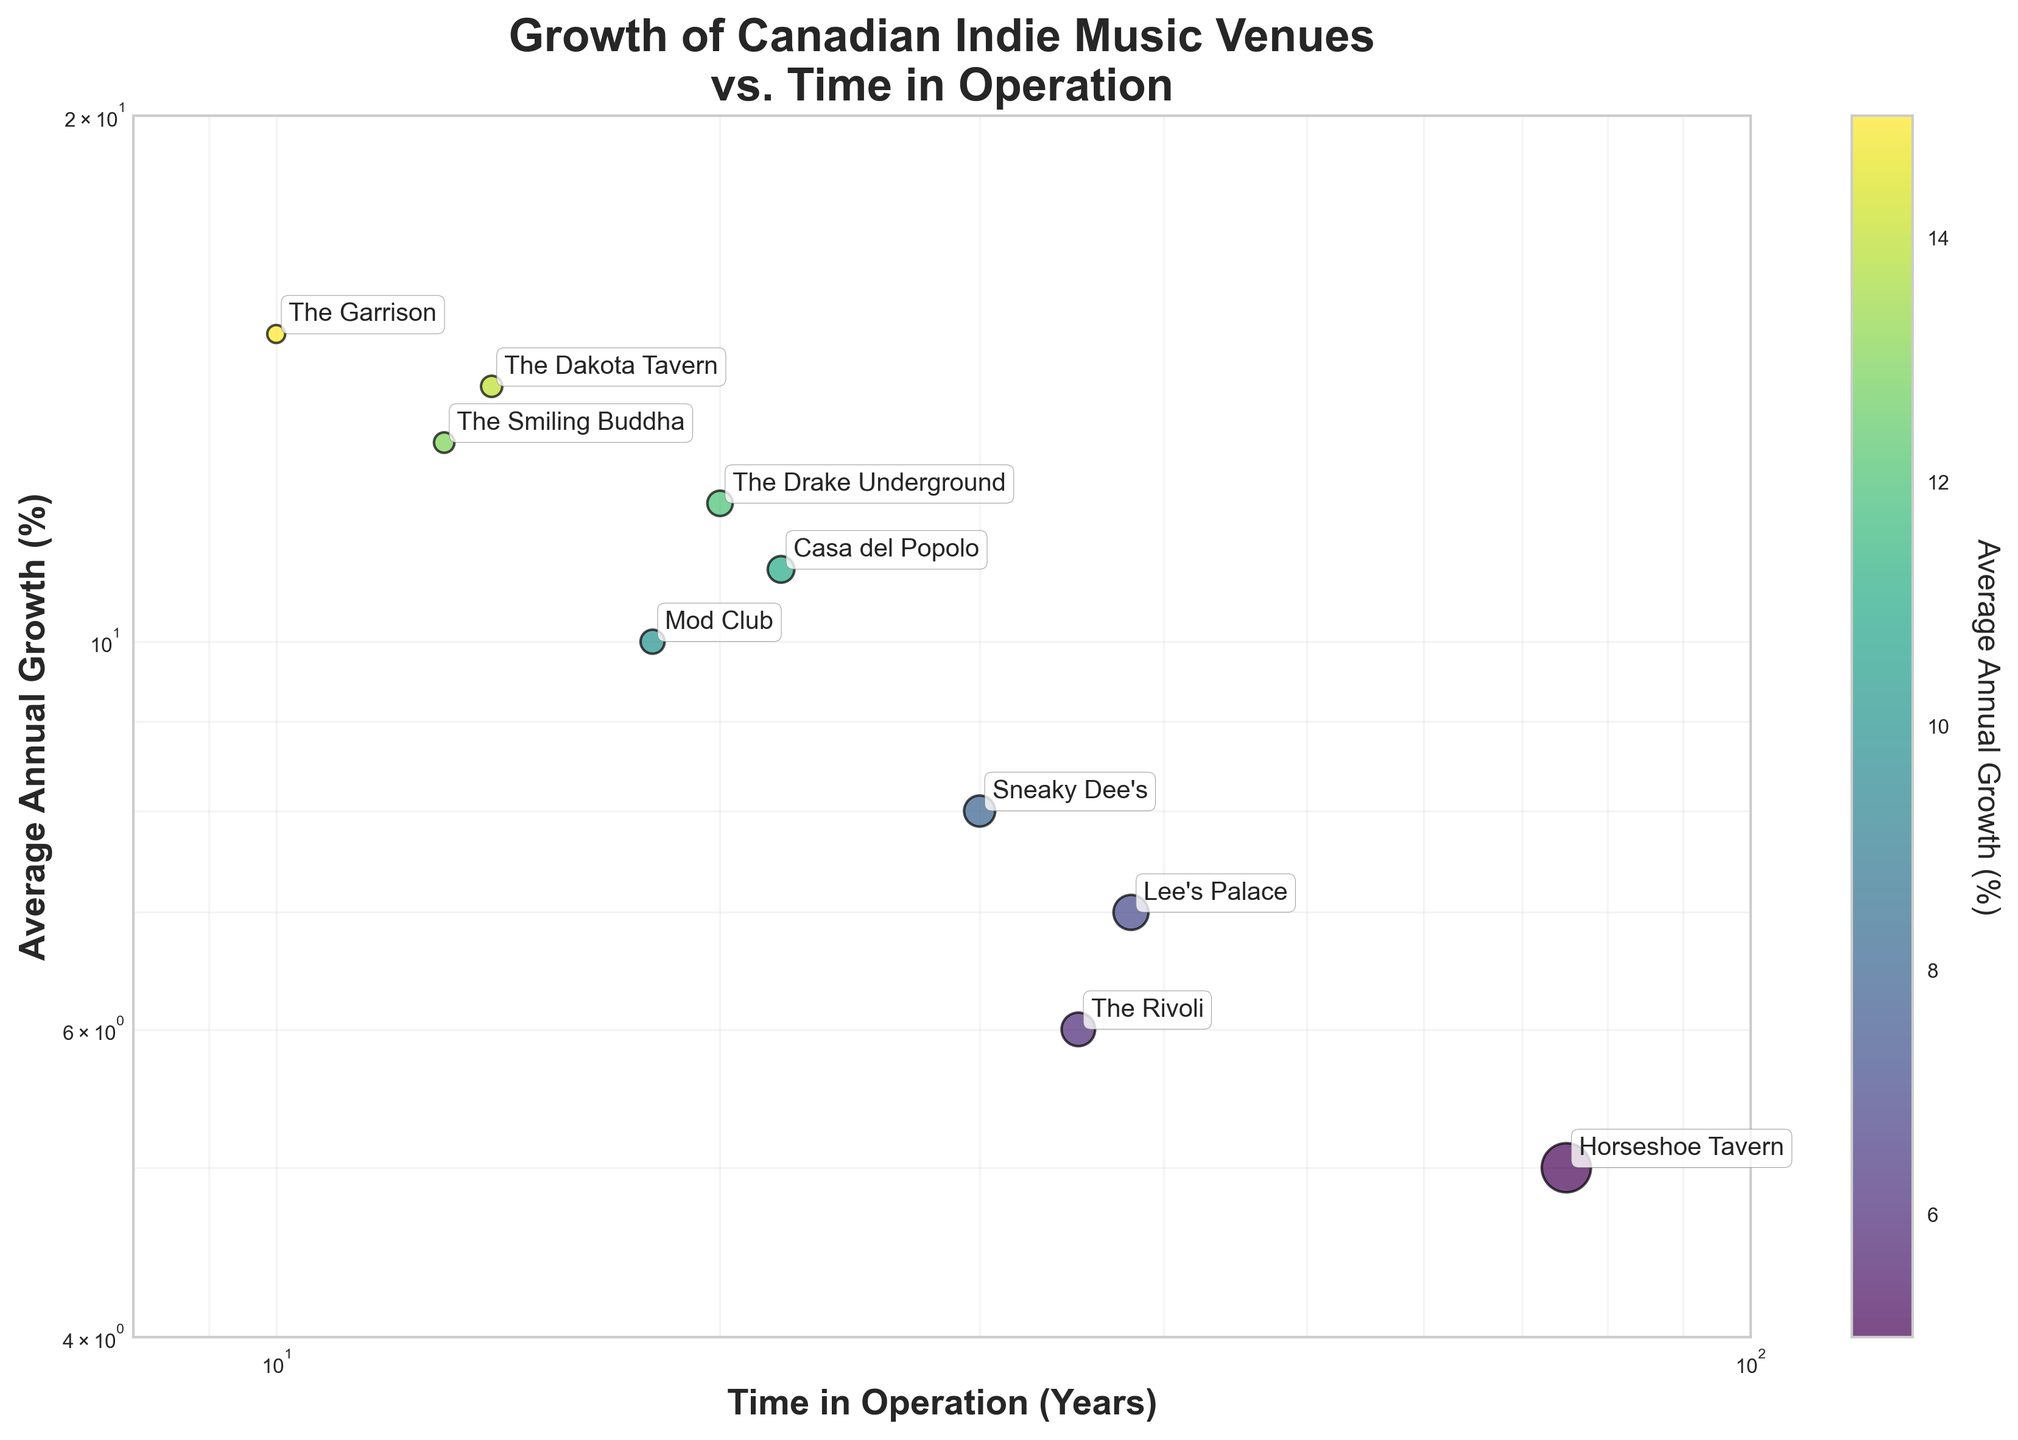Which venue has the highest average annual growth percentage? Locate the data point with the largest value on the y-axis. The Smiling Buddha shows an average annual growth percentage of 13%.
Answer: The Smiling Buddha How long has the Horseshoe Tavern been in operation? Identify the position of the Horseshoe Tavern on the x-axis, corresponding to the time in operation. It is positioned at 75 years.
Answer: 75 years Which venue shows the smallest growth since its inception? Find the data point with the lowest value on the y-axis. Horseshoe Tavern, with a growth percentage of 5%, is the smallest.
Answer: Horseshoe Tavern What is the general trend between the time in operation and the average annual growth percentage? Observe the scatter plot to determine the general relationship between the x-axis (time in operation) and the y-axis (average annual growth). Venues with a longer time in operation generally have a lower average annual growth percentage.
Answer: Inversely proportional What is the combined average growth percentage of venues that have been in operation for more than 20 years? Identify venues with more than 20 years in operation: Horseshoe Tavern (5%), Sneaky Dee's (8%), The Drake Underground (12%), The Rivoli (6%), Lee's Palace (7%), Casa del Popolo (11%). Sum these values: 5 + 8 + 12 + 6 + 7 + 11 = 49. Average this sum by dividing by the number of venues (6): 49/6 ≈ 8.17%.
Answer: 8.17% Is there any venue that has been in operation for less than 15 years and has an average annual growth over 10%? Identify points meeting these criteria: The Dakota Tavern (14 years, 14%), and The Smiling Buddha (13 years, 13%). Both meet the requirement.
Answer: Yes, two venues How does The Garrison compare to The Dakota Tavern in terms of growth and time in operation? Locate both venues on the plot. The Garrison has been in operation for 10 years with a 15% growth. The Dakota Tavern shows 14 years in operation with 14% growth. Thus, The Garrison has a higher growth rate with fewer years in operation.
Answer: The Garrison has higher growth but fewer years in operation Which venue has the second-highest average annual growth percentage after The Garrison? Compare the annual growth percentages. The venues with the highest growth are The Garrison (15%), The Dakota Tavern (14%), and The Smiling Buddha (13%). Therefore, The Dakota Tavern is second after The Garrison.
Answer: The Dakota Tavern Given the log scales, which venue appears more prominent due to its combination of growth rate and time in operation? On a log-log plot, consider both coordinates and size. The Garrison appears prominent with its combination of high growth rate (15%) and reasonable time in operation (10 years). Additionally, venues like The Dakota Tavern and The Smiling Buddha are noticeable.
Answer: The Garrison is most prominent 